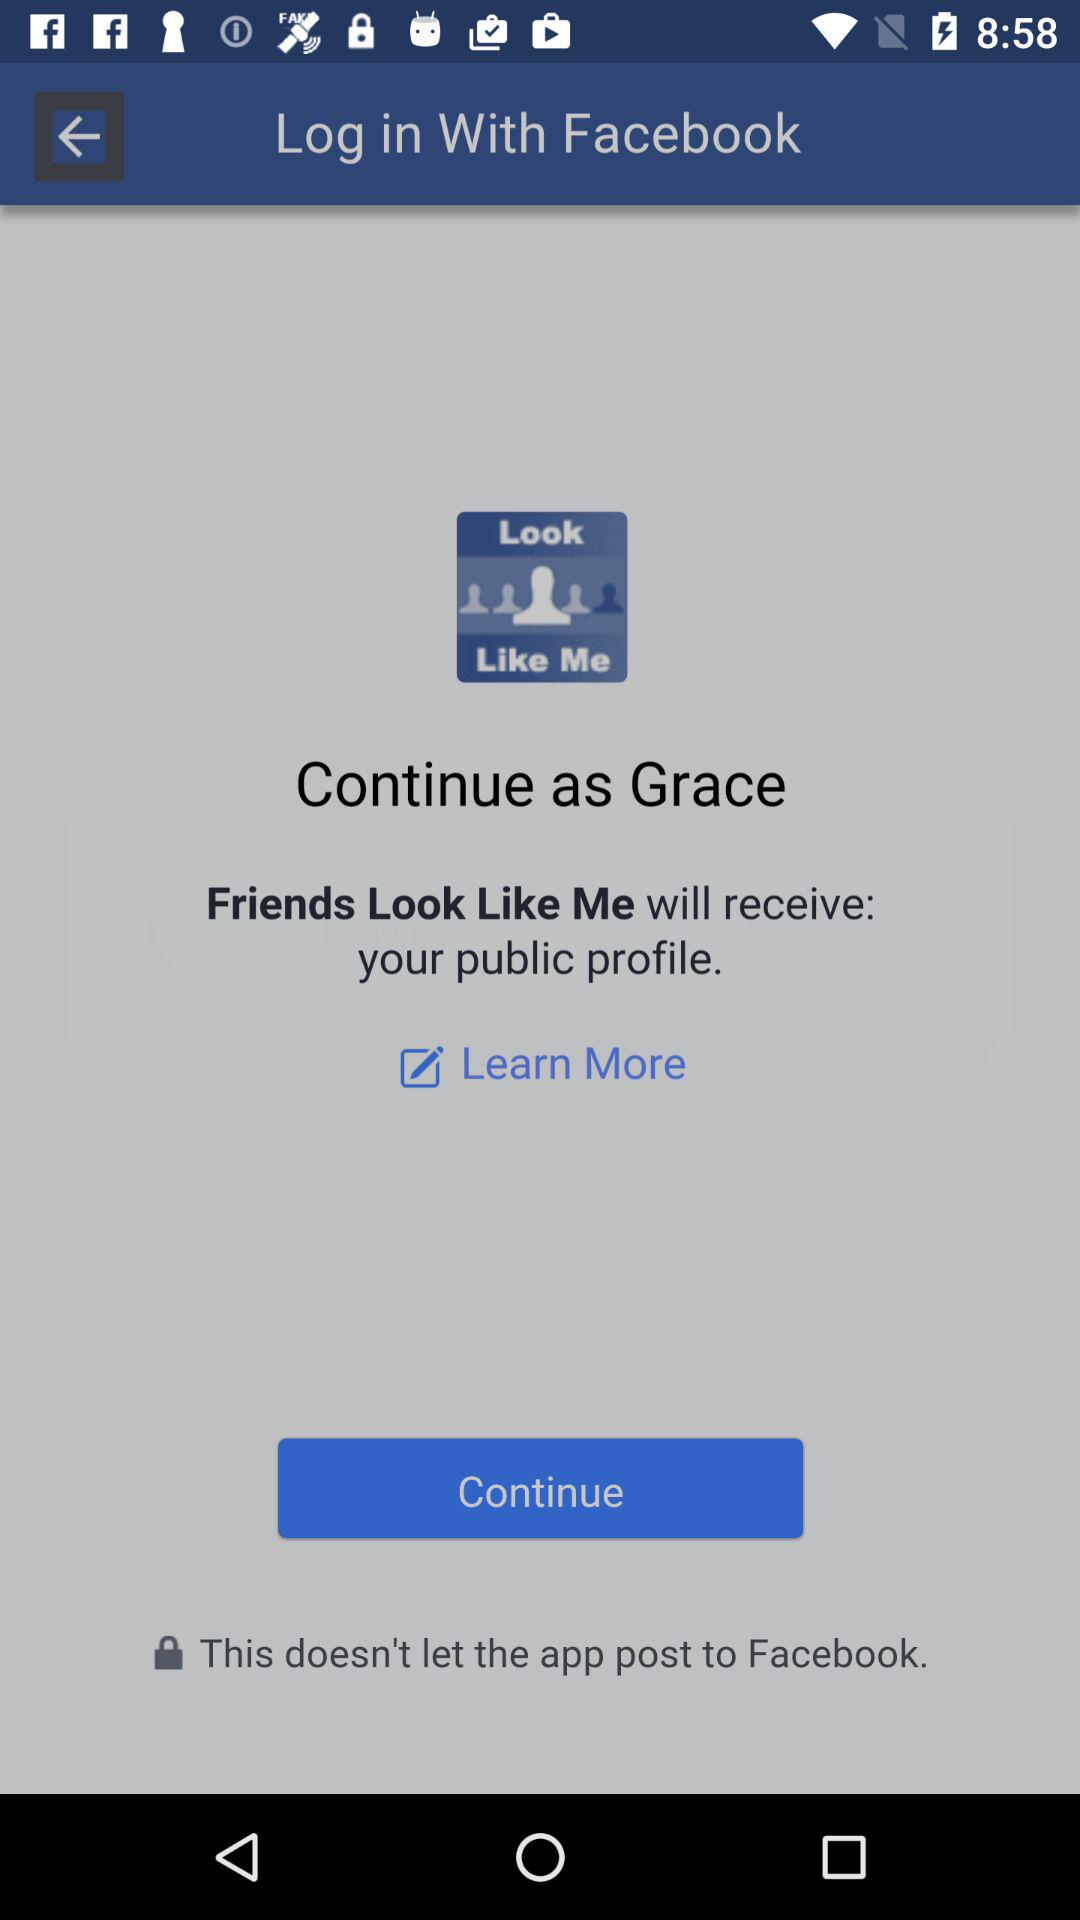What application can be used to log in to the profile? The application that can be used to log in is "Facebook". 